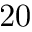Convert formula to latex. <formula><loc_0><loc_0><loc_500><loc_500>2 0</formula> 